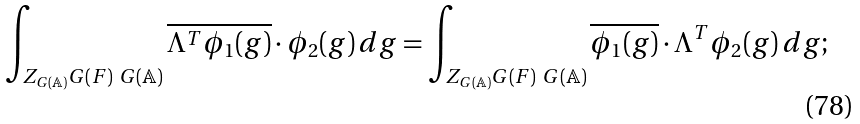Convert formula to latex. <formula><loc_0><loc_0><loc_500><loc_500>\int _ { Z _ { G ( \mathbb { A } ) } G ( F ) \ G ( \mathbb { A } ) } \overline { \Lambda ^ { T } \phi _ { 1 } ( g ) } \cdot \phi _ { 2 } ( g ) \, d g = \int _ { Z _ { G ( \mathbb { A } ) } G ( F ) \ G ( \mathbb { A } ) } \overline { \phi _ { 1 } ( g ) } \cdot \Lambda ^ { T } \phi _ { 2 } ( g ) \, d g ;</formula> 